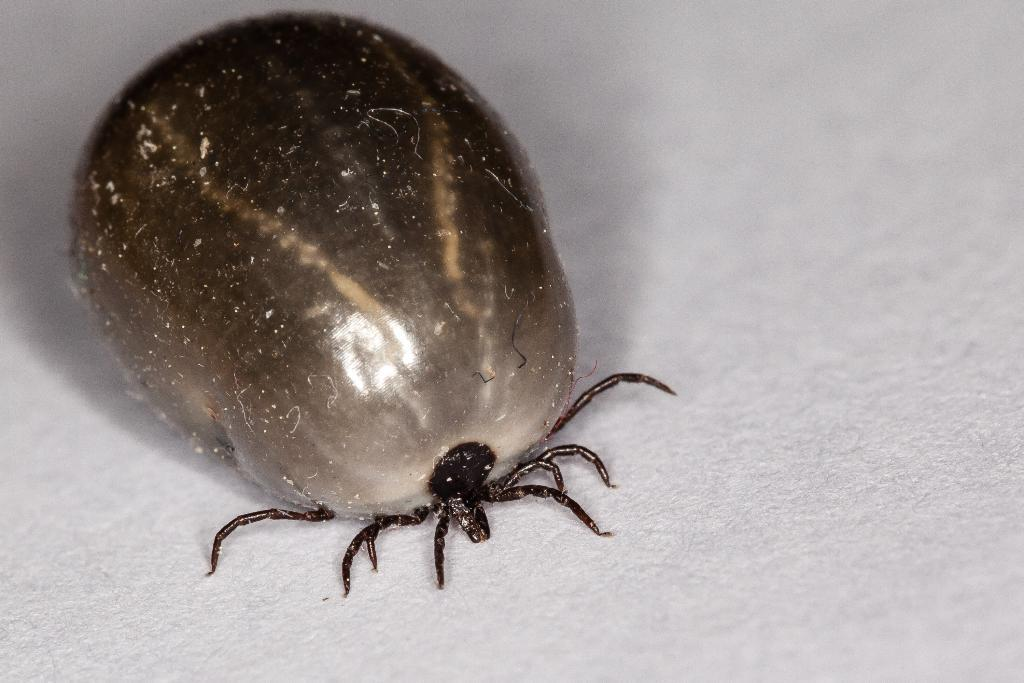What type of creature can be seen in the image? There is an insect in the image. What color is the background of the image? The background of the image is white. What type of guide can be seen in the image? There is no guide present in the image; it features an insect and a white background. What type of sound can be heard coming from the insect in the image? There is no sound present in the image, as it is a static image and not a video or audio recording. 